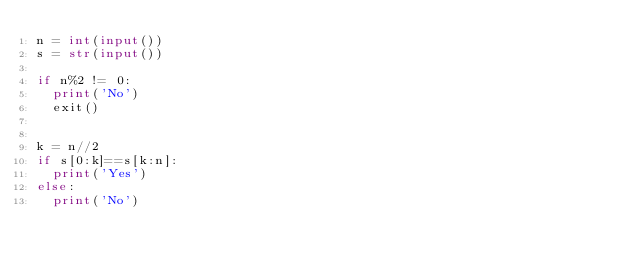Convert code to text. <code><loc_0><loc_0><loc_500><loc_500><_Python_>n = int(input())
s = str(input())

if n%2 != 0:
  print('No')
  exit()


k = n//2
if s[0:k]==s[k:n]:
  print('Yes')
else:
  print('No')</code> 